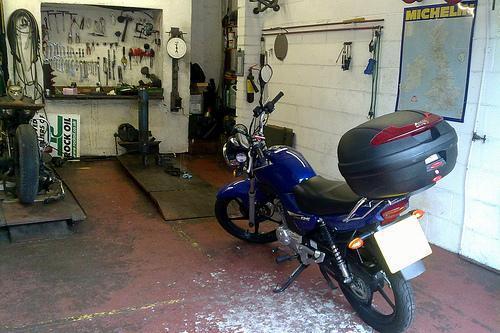How many wheels are on the motorcycle?
Give a very brief answer. 2. 